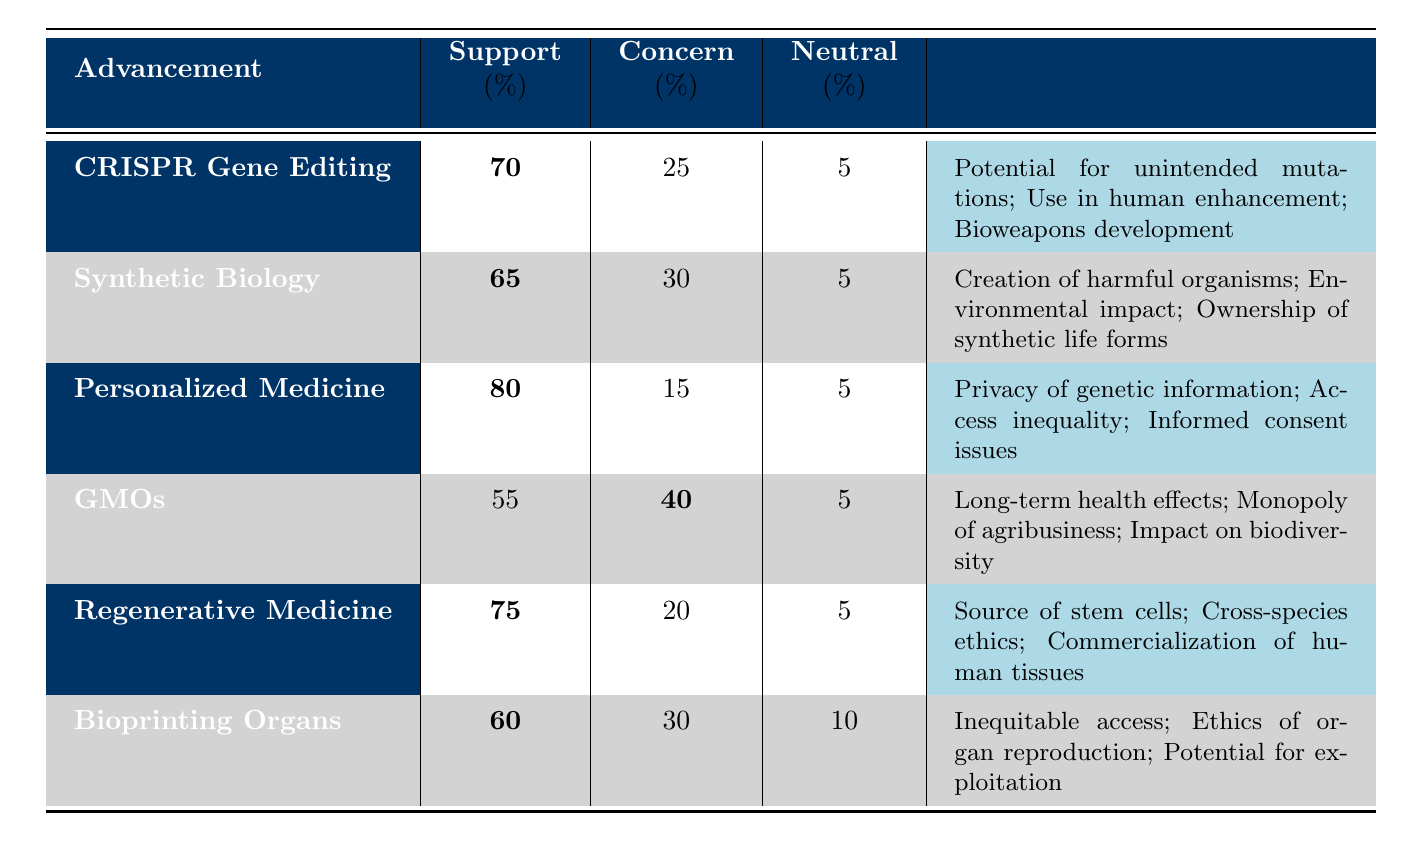What is the support percentage for CRISPR Gene Editing? The table shows that the support percentage for CRISPR Gene Editing is bolded, indicating it is an important data point; the value is 70%.
Answer: 70% Which advancement has the highest concern percentage? The concern percentages for each advancement are noted; GMOs have the highest concern percentage at 40%.
Answer: GMOs What are the ethical concerns associated with Personalized Medicine? The ethical concerns listed for Personalized Medicine are, 'Privacy of genetic information', 'Access inequality', and 'Informed consent issues', which can be found in the last column.
Answer: Privacy of genetic information; Access inequality; Informed consent issues Calculate the average support percentage for all advancements listed. Summing the support percentages: 70 (CRISPR) + 65 (Synthetic Biology) + 80 (Personalized Medicine) + 55 (GMOs) + 75 (Regenerative Medicine) + 60 (Bioprinting) = 405. There are 6 advancements, so 405/6 = 67.5.
Answer: 67.5 Is the support percentage for Bioprinting Organs greater than the support percentage for Synthetic Biology? The support for Bioprinting Organs is 60%, and for Synthetic Biology, it is 65%. Since 60% is not greater than 65%, the answer is no.
Answer: No What percentage of people remained neutral about GMOs? The neutral percentage for GMOs is given in the table as 5%.
Answer: 5% Which advancement has the lowest support percentage, and what is that percentage? By comparing the support percentages, GMOs have the lowest value at 55%.
Answer: GMOs; 55% How many advancements have a support percentage of 70% or higher? The advancements with 70% or more support are CRISPR Gene Editing (70%), Personalized Medicine (80%), and Regenerative Medicine (75%), totaling 3 advancements.
Answer: 3 What is the difference in concern percentage between Regenerative Medicine and CRISPR Gene Editing? The concern percentage for Regenerative Medicine is 20% and for CRISPR Gene Editing is 25%. The difference is 25% - 20% = 5%.
Answer: 5% Are the ethical concerns related to Bioprinting Organs more focused on access or on organ reproduction? The ethical concerns for Bioprinting Organs include 'Inequitable access' and 'Ethics of organ reproduction'. Both concerns are present, but access appears to be a primary focus due to its listing first.
Answer: Yes, they are more focused on access 